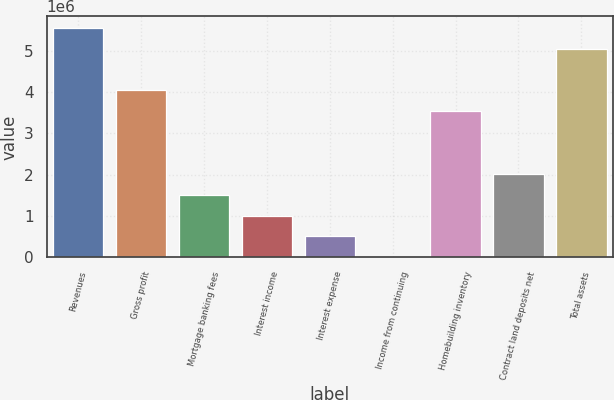<chart> <loc_0><loc_0><loc_500><loc_500><bar_chart><fcel>Revenues<fcel>Gross profit<fcel>Mortgage banking fees<fcel>Interest income<fcel>Interest expense<fcel>Income from continuing<fcel>Homebuilding inventory<fcel>Contract land deposits net<fcel>Total assets<nl><fcel>5.553e+06<fcel>4.03856e+06<fcel>1.51449e+06<fcel>1.00968e+06<fcel>504867<fcel>54.14<fcel>3.53375e+06<fcel>2.01931e+06<fcel>5.04819e+06<nl></chart> 